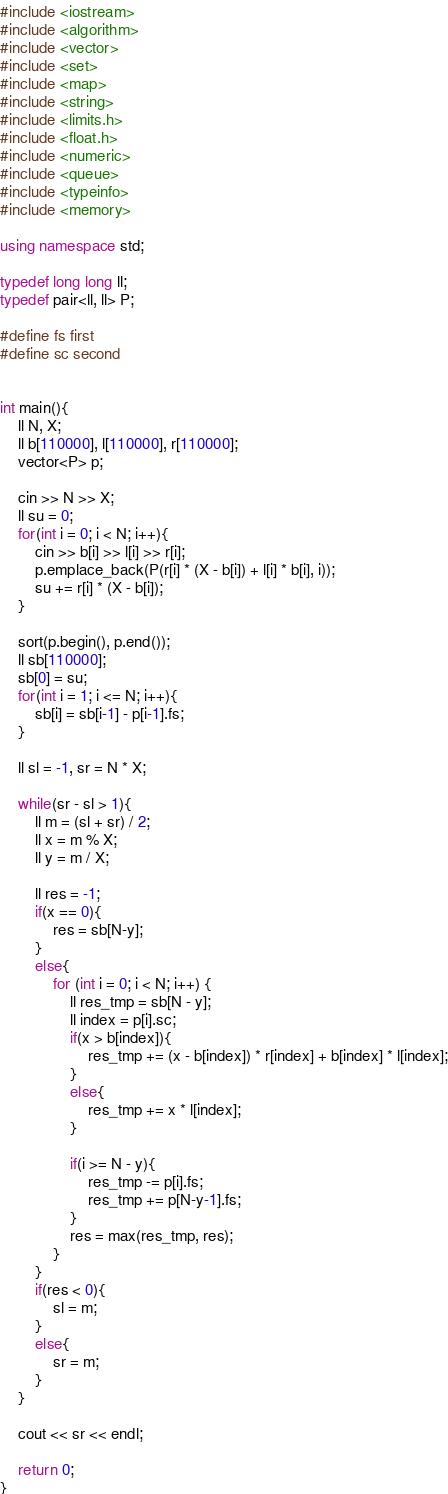Convert code to text. <code><loc_0><loc_0><loc_500><loc_500><_C++_>#include <iostream>
#include <algorithm>
#include <vector>
#include <set>
#include <map>
#include <string>
#include <limits.h>
#include <float.h>
#include <numeric>
#include <queue>
#include <typeinfo>
#include <memory>

using namespace std;

typedef long long ll;
typedef pair<ll, ll> P;

#define fs first
#define sc second


int main(){
    ll N, X;
    ll b[110000], l[110000], r[110000];
    vector<P> p;

    cin >> N >> X;
    ll su = 0;
    for(int i = 0; i < N; i++){
        cin >> b[i] >> l[i] >> r[i];
        p.emplace_back(P(r[i] * (X - b[i]) + l[i] * b[i], i));
        su += r[i] * (X - b[i]);
    }

    sort(p.begin(), p.end());
    ll sb[110000];
    sb[0] = su;
    for(int i = 1; i <= N; i++){
        sb[i] = sb[i-1] - p[i-1].fs;
    }

    ll sl = -1, sr = N * X;

    while(sr - sl > 1){
        ll m = (sl + sr) / 2;
        ll x = m % X;
        ll y = m / X;

        ll res = -1;
        if(x == 0){
            res = sb[N-y];
        }
        else{
            for (int i = 0; i < N; i++) {
                ll res_tmp = sb[N - y];
                ll index = p[i].sc;
                if(x > b[index]){
                    res_tmp += (x - b[index]) * r[index] + b[index] * l[index];
                }
                else{
                    res_tmp += x * l[index];
                }

                if(i >= N - y){
                    res_tmp -= p[i].fs;
                    res_tmp += p[N-y-1].fs;
                }
                res = max(res_tmp, res);
            }
        }
        if(res < 0){
            sl = m;
        }
        else{
            sr = m;
        }
    }

    cout << sr << endl;

    return 0;
}
</code> 